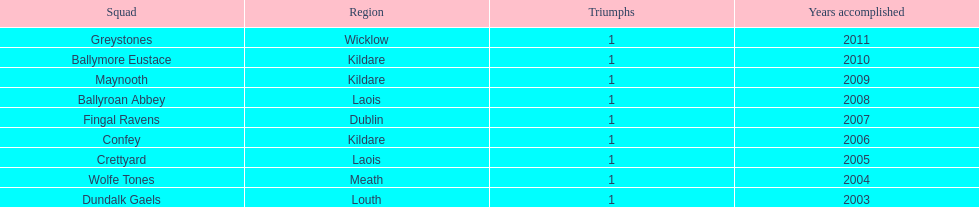Which is the foremost team from the graph? Greystones. 